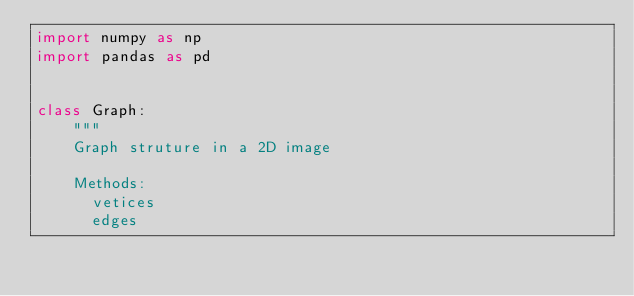<code> <loc_0><loc_0><loc_500><loc_500><_Python_>import numpy as np
import pandas as pd


class Graph:
    """
    Graph struture in a 2D image

    Methods:
      vetices
      edges</code> 